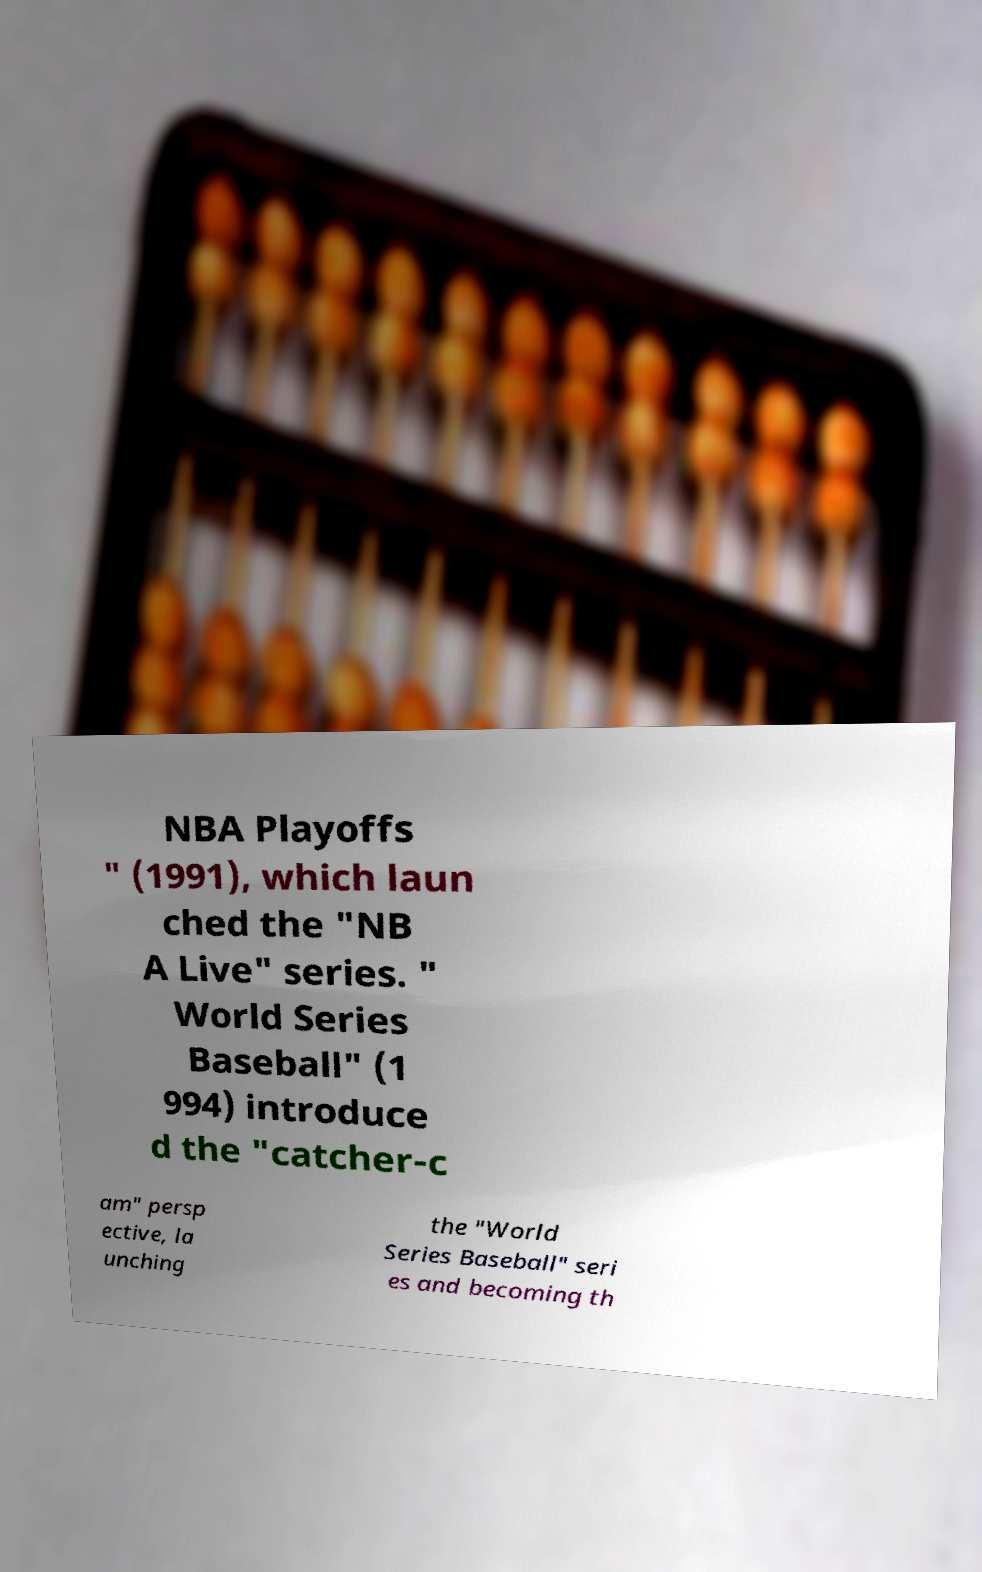There's text embedded in this image that I need extracted. Can you transcribe it verbatim? NBA Playoffs " (1991), which laun ched the "NB A Live" series. " World Series Baseball" (1 994) introduce d the "catcher-c am" persp ective, la unching the "World Series Baseball" seri es and becoming th 